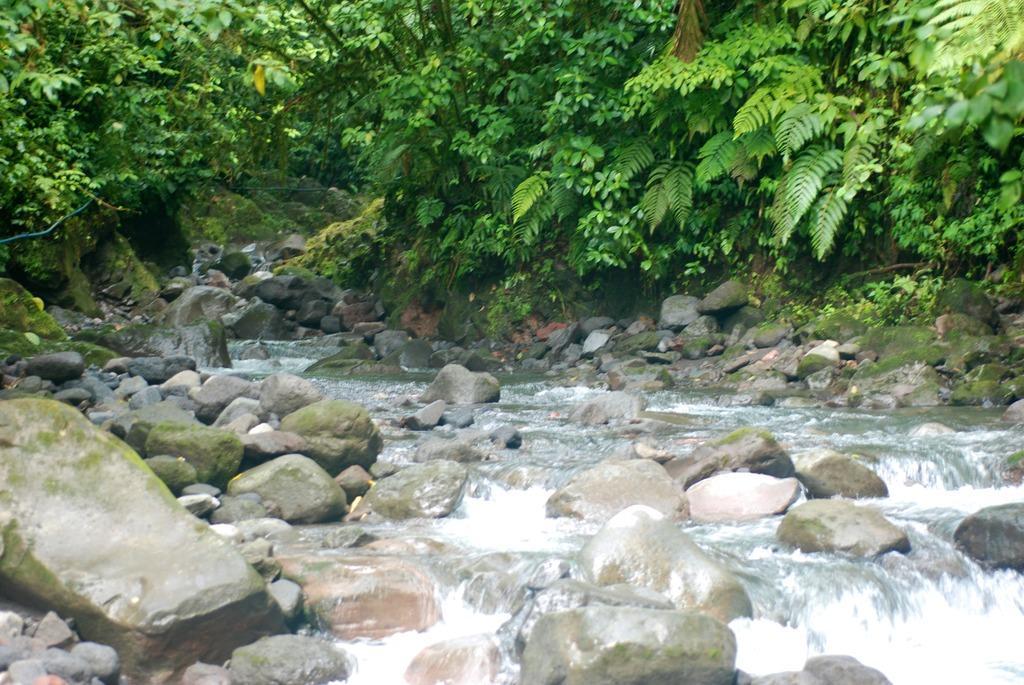Please provide a concise description of this image. In this image we can see so many trees, plants, bushes and grass. There are so many stones and water flowing on the rocks. 